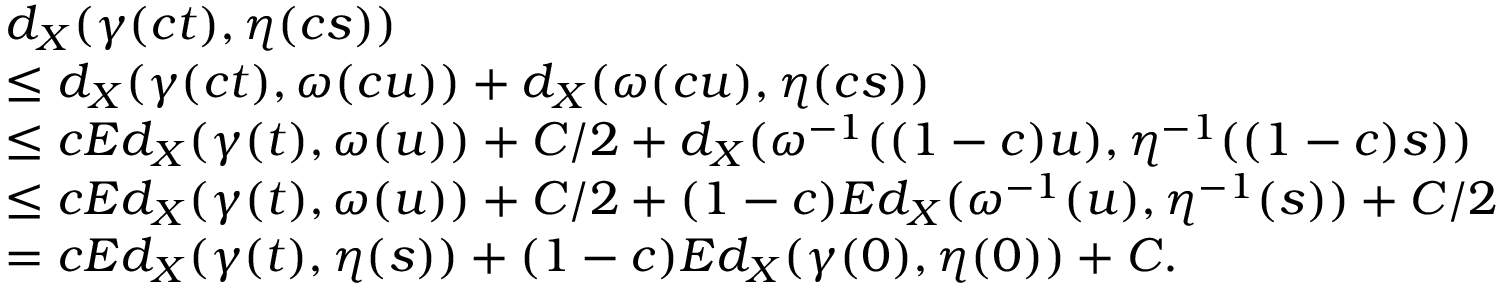<formula> <loc_0><loc_0><loc_500><loc_500>\begin{array} { r l } & { d _ { X } ( \gamma ( c t ) , \eta ( c s ) ) } \\ & { \leq d _ { X } ( \gamma ( c t ) , \omega ( c u ) ) + d _ { X } ( \omega ( c u ) , \eta ( c s ) ) } \\ & { \leq c E d _ { X } ( \gamma ( t ) , \omega ( u ) ) + C / 2 + d _ { X } ( \omega ^ { - 1 } ( ( 1 - c ) u ) , \eta ^ { - 1 } ( ( 1 - c ) s ) ) } \\ & { \leq c E d _ { X } ( \gamma ( t ) , \omega ( u ) ) + C / 2 + ( 1 - c ) E d _ { X } ( \omega ^ { - 1 } ( u ) , \eta ^ { - 1 } ( s ) ) + C / 2 } \\ & { = c E d _ { X } ( \gamma ( t ) , \eta ( s ) ) + ( 1 - c ) E d _ { X } ( \gamma ( 0 ) , \eta ( 0 ) ) + C . } \end{array}</formula> 